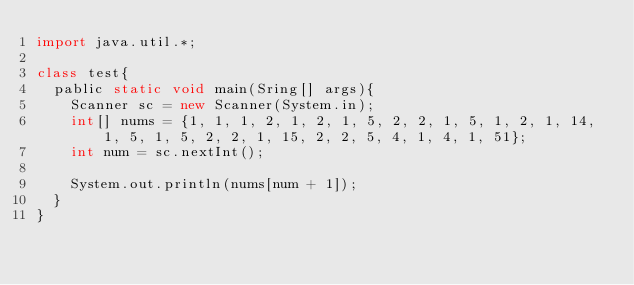<code> <loc_0><loc_0><loc_500><loc_500><_Java_>import java.util.*;

class test{
  pablic static void main(Sring[] args){
    Scanner sc = new Scanner(System.in);
	int[] nums = {1, 1, 1, 2, 1, 2, 1, 5, 2, 2, 1, 5, 1, 2, 1, 14, 1, 5, 1, 5, 2, 2, 1, 15, 2, 2, 5, 4, 1, 4, 1, 51};
	int num = sc.nextInt();
    
    System.out.println(nums[num + 1]);
  }
}</code> 